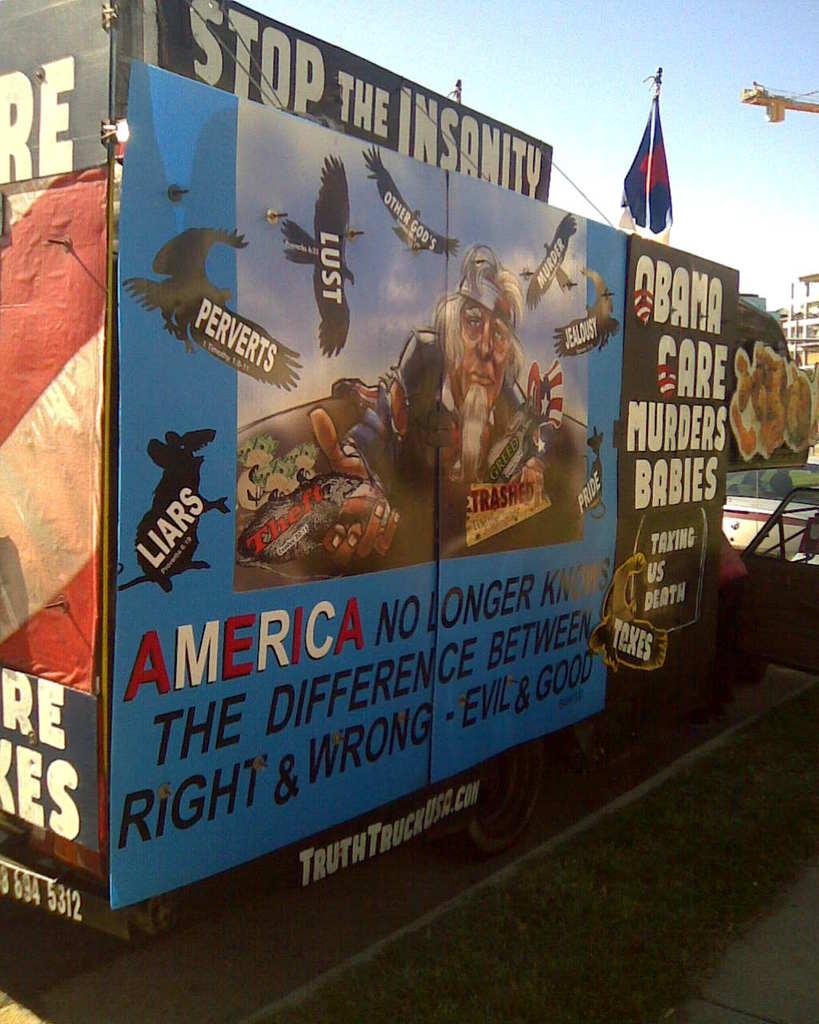What country does this poster talk about?
Give a very brief answer. America. What did obama care do?
Make the answer very short. Murders babies. 